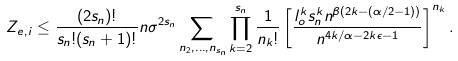Convert formula to latex. <formula><loc_0><loc_0><loc_500><loc_500>Z _ { e , i } \leq \frac { ( 2 s _ { n } ) ! } { s _ { n } ! ( s _ { n } + 1 ) ! } n \sigma ^ { 2 s _ { n } } \sum _ { n _ { 2 } , \dots , n _ { s _ { n } } } \prod _ { k = 2 } ^ { s _ { n } } \frac { 1 } { n _ { k } ! } \left [ \frac { l _ { o } ^ { k } s _ { n } ^ { k } n ^ { \beta ( 2 k - ( \alpha / 2 - 1 ) ) } } { n ^ { 4 k / \alpha - 2 k \epsilon - 1 } } \right ] ^ { n _ { k } } .</formula> 